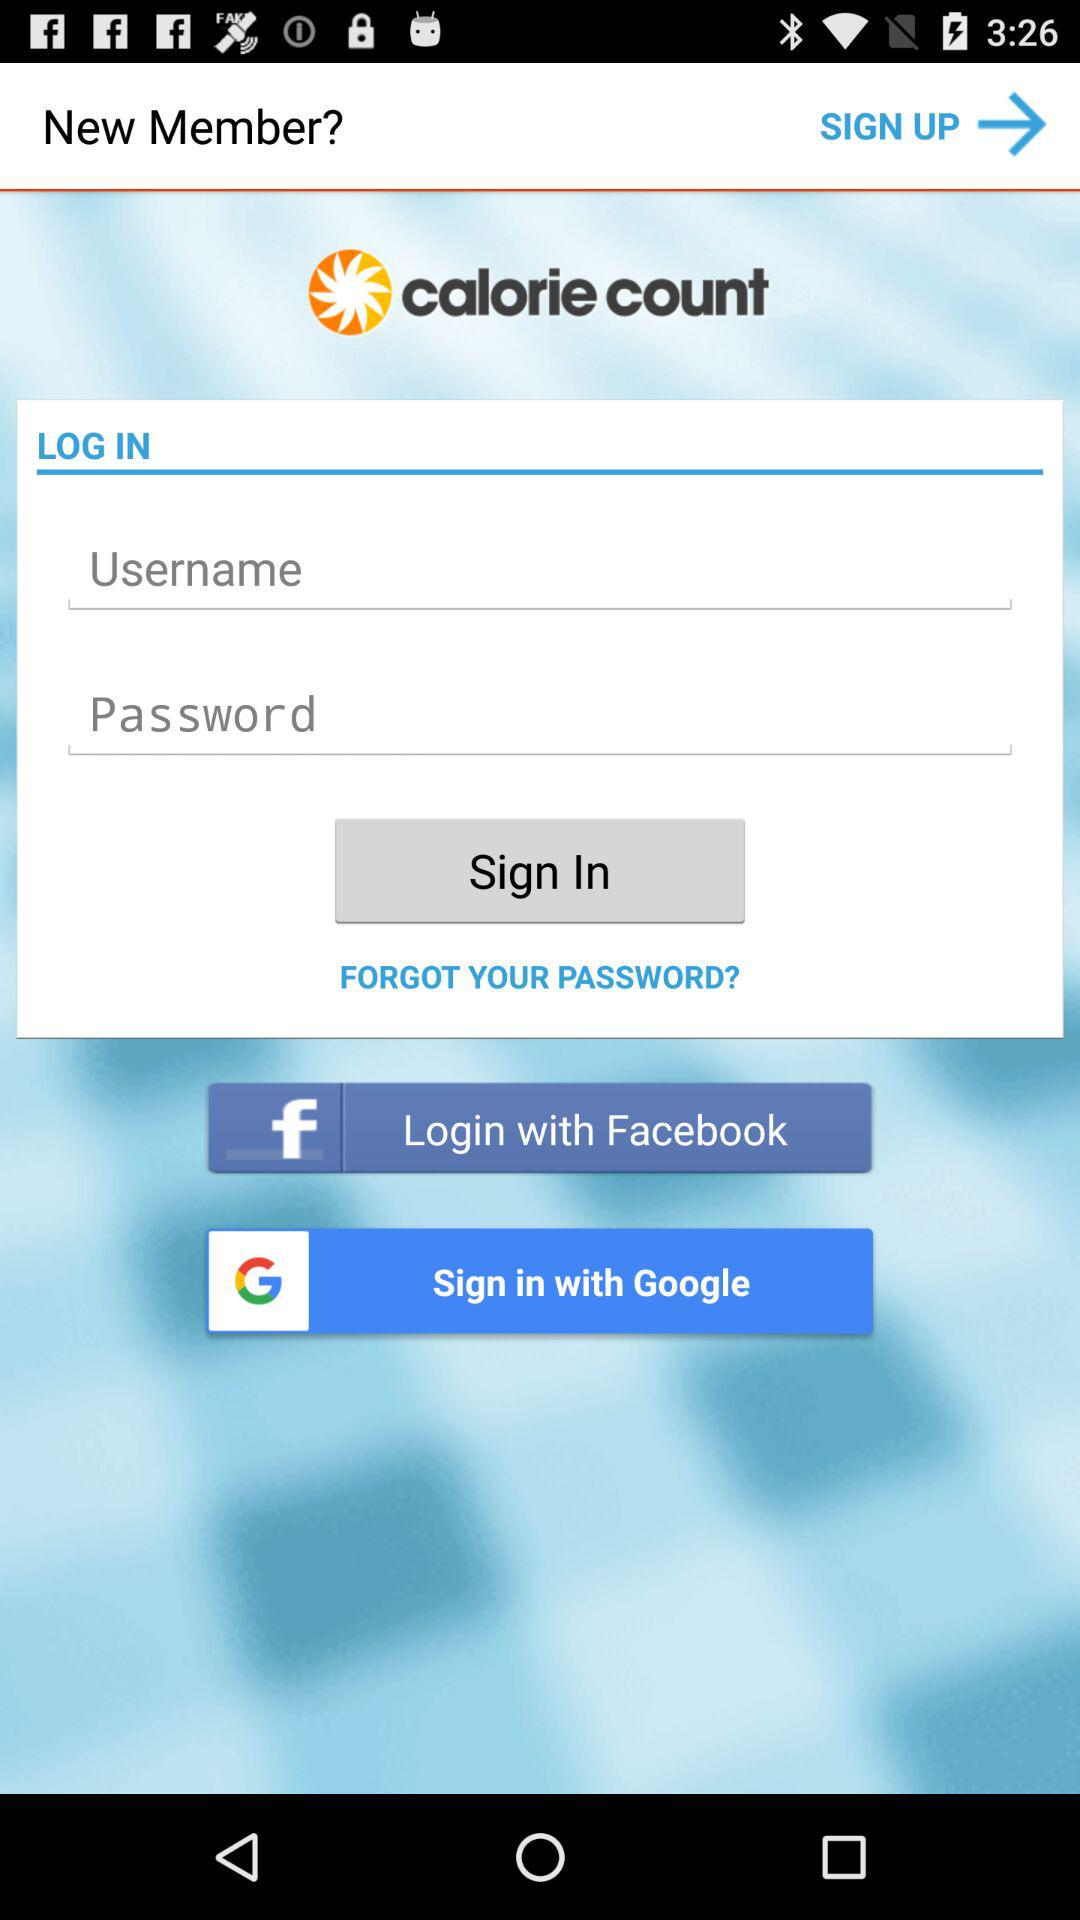What is the application name? The application name is "calorie count". 